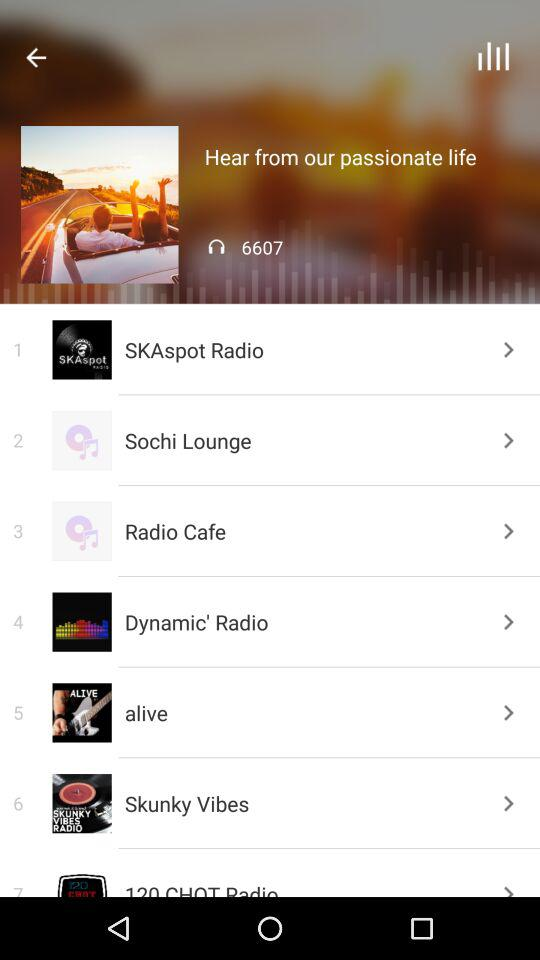The name of the album which is currently playing? The name of the album is "Hear from our passionate life". 